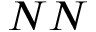Convert formula to latex. <formula><loc_0><loc_0><loc_500><loc_500>N N</formula> 